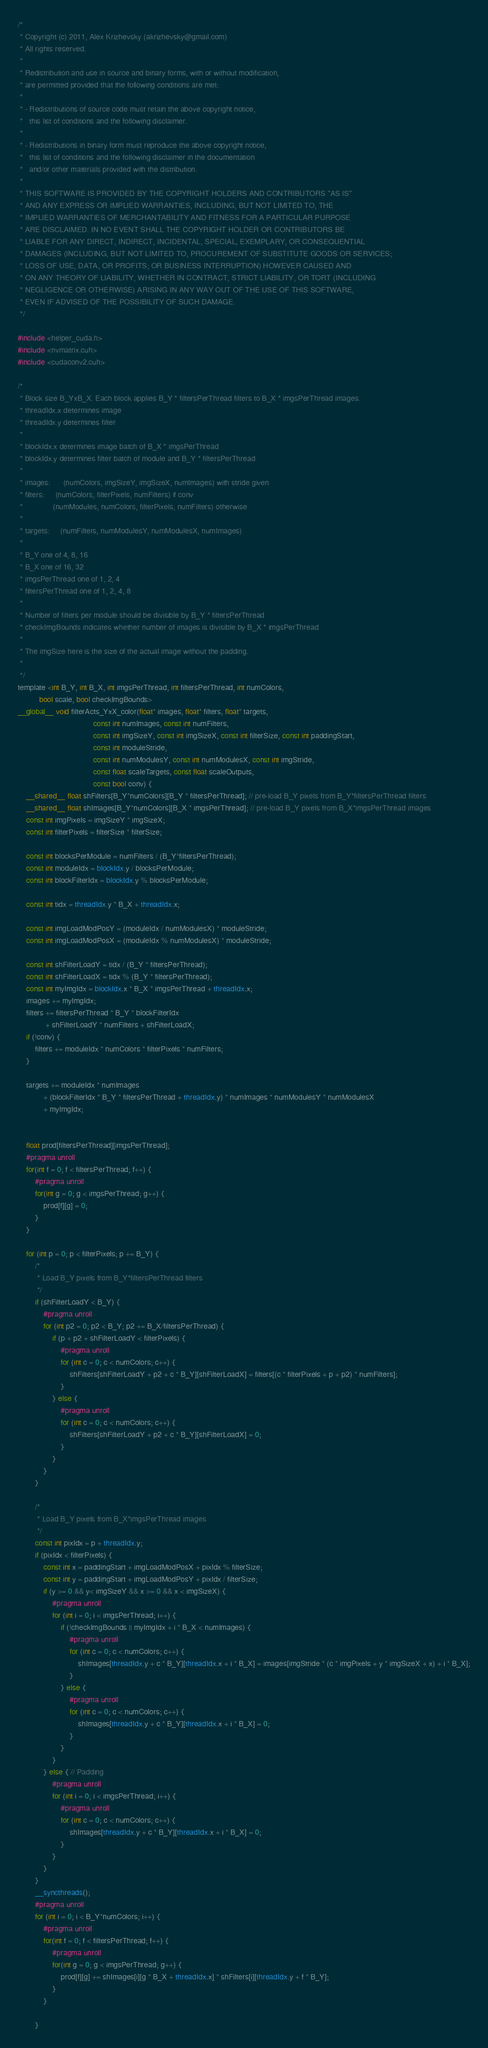<code> <loc_0><loc_0><loc_500><loc_500><_Cuda_>/* 
 * Copyright (c) 2011, Alex Krizhevsky (akrizhevsky@gmail.com)
 * All rights reserved.
 *
 * Redistribution and use in source and binary forms, with or without modification,
 * are permitted provided that the following conditions are met:
 *
 * - Redistributions of source code must retain the above copyright notice,
 *   this list of conditions and the following disclaimer.
 * 
 * - Redistributions in binary form must reproduce the above copyright notice,
 *   this list of conditions and the following disclaimer in the documentation
 *   and/or other materials provided with the distribution.
 *
 * THIS SOFTWARE IS PROVIDED BY THE COPYRIGHT HOLDERS AND CONTRIBUTORS "AS IS"
 * AND ANY EXPRESS OR IMPLIED WARRANTIES, INCLUDING, BUT NOT LIMITED TO, THE
 * IMPLIED WARRANTIES OF MERCHANTABILITY AND FITNESS FOR A PARTICULAR PURPOSE
 * ARE DISCLAIMED. IN NO EVENT SHALL THE COPYRIGHT HOLDER OR CONTRIBUTORS BE
 * LIABLE FOR ANY DIRECT, INDIRECT, INCIDENTAL, SPECIAL, EXEMPLARY, OR CONSEQUENTIAL
 * DAMAGES (INCLUDING, BUT NOT LIMITED TO, PROCUREMENT OF SUBSTITUTE GOODS OR SERVICES;
 * LOSS OF USE, DATA, OR PROFITS; OR BUSINESS INTERRUPTION) HOWEVER CAUSED AND
 * ON ANY THEORY OF LIABILITY, WHETHER IN CONTRACT, STRICT LIABILITY, OR TORT (INCLUDING
 * NEGLIGENCE OR OTHERWISE) ARISING IN ANY WAY OUT OF THE USE OF THIS SOFTWARE,
 * EVEN IF ADVISED OF THE POSSIBILITY OF SUCH DAMAGE.
 */

#include <helper_cuda.h>
#include <nvmatrix.cuh>
#include <cudaconv2.cuh>

/*
 * Block size B_YxB_X. Each block applies B_Y * filtersPerThread filters to B_X * imgsPerThread images.
 * threadIdx.x determines image
 * threadIdx.y determines filter
 *
 * blockIdx.x determines image batch of B_X * imgsPerThread
 * blockIdx.y determines filter batch of module and B_Y * filtersPerThread
 *
 * images:      (numColors, imgSizeY, imgSizeX, numImages) with stride given
 * filters:     (numColors, filterPixels, numFilters) if conv
 *              (numModules, numColors, filterPixels, numFilters) otherwise
 *
 * targets:     (numFilters, numModulesY, numModulesX, numImages)
 *
 * B_Y one of 4, 8, 16
 * B_X one of 16, 32
 * imgsPerThread one of 1, 2, 4
 * filtersPerThread one of 1, 2, 4, 8
 *
 * Number of filters per module should be divisible by B_Y * filtersPerThread
 * checkImgBounds indicates whether number of images is divisible by B_X * imgsPerThread
 *
 * The imgSize here is the size of the actual image without the padding.
 *
 */
template <int B_Y, int B_X, int imgsPerThread, int filtersPerThread, int numColors,
          bool scale, bool checkImgBounds>
__global__ void filterActs_YxX_color(float* images, float* filters, float* targets,
                                   const int numImages, const int numFilters,
                                   const int imgSizeY, const int imgSizeX, const int filterSize, const int paddingStart,
                                   const int moduleStride,
                                   const int numModulesY, const int numModulesX, const int imgStride,
                                   const float scaleTargets, const float scaleOutputs,
                                   const bool conv) {
    __shared__ float shFilters[B_Y*numColors][B_Y * filtersPerThread]; // pre-load B_Y pixels from B_Y*filtersPerThread filters
    __shared__ float shImages[B_Y*numColors][B_X * imgsPerThread]; // pre-load B_Y pixels from B_X*imgsPerThread images
    const int imgPixels = imgSizeY * imgSizeX;
    const int filterPixels = filterSize * filterSize;

    const int blocksPerModule = numFilters / (B_Y*filtersPerThread);
    const int moduleIdx = blockIdx.y / blocksPerModule;
    const int blockFilterIdx = blockIdx.y % blocksPerModule;

    const int tidx = threadIdx.y * B_X + threadIdx.x;

    const int imgLoadModPosY = (moduleIdx / numModulesX) * moduleStride;
    const int imgLoadModPosX = (moduleIdx % numModulesX) * moduleStride;

    const int shFilterLoadY = tidx / (B_Y * filtersPerThread);
    const int shFilterLoadX = tidx % (B_Y * filtersPerThread);
    const int myImgIdx = blockIdx.x * B_X * imgsPerThread + threadIdx.x;
    images += myImgIdx;
    filters += filtersPerThread * B_Y * blockFilterIdx
             + shFilterLoadY * numFilters + shFilterLoadX;
    if (!conv) {
        filters += moduleIdx * numColors * filterPixels * numFilters;
    }

    targets += moduleIdx * numImages
            + (blockFilterIdx * B_Y * filtersPerThread + threadIdx.y) * numImages * numModulesY * numModulesX
            + myImgIdx;


    float prod[filtersPerThread][imgsPerThread];
    #pragma unroll
    for(int f = 0; f < filtersPerThread; f++) {
        #pragma unroll
        for(int g = 0; g < imgsPerThread; g++) {
            prod[f][g] = 0;
        }
    }

    for (int p = 0; p < filterPixels; p += B_Y) {
        /*
         * Load B_Y pixels from B_Y*filtersPerThread filters
         */
        if (shFilterLoadY < B_Y) {
            #pragma unroll
            for (int p2 = 0; p2 < B_Y; p2 += B_X/filtersPerThread) {
                if (p + p2 + shFilterLoadY < filterPixels) {
                    #pragma unroll
                    for (int c = 0; c < numColors; c++) {
                        shFilters[shFilterLoadY + p2 + c * B_Y][shFilterLoadX] = filters[(c * filterPixels + p + p2) * numFilters];
                    }
                } else {
                    #pragma unroll
                    for (int c = 0; c < numColors; c++) {
                        shFilters[shFilterLoadY + p2 + c * B_Y][shFilterLoadX] = 0;
                    }
                }
            }
        }

        /*
         * Load B_Y pixels from B_X*imgsPerThread images
         */
        const int pixIdx = p + threadIdx.y;
        if (pixIdx < filterPixels) {
            const int x = paddingStart + imgLoadModPosX + pixIdx % filterSize;
            const int y = paddingStart + imgLoadModPosY + pixIdx / filterSize;
            if (y >= 0 && y< imgSizeY && x >= 0 && x < imgSizeX) {
                #pragma unroll
                for (int i = 0; i < imgsPerThread; i++) {
                    if (!checkImgBounds || myImgIdx + i * B_X < numImages) {
                        #pragma unroll
                        for (int c = 0; c < numColors; c++) {
                            shImages[threadIdx.y + c * B_Y][threadIdx.x + i * B_X] = images[imgStride * (c * imgPixels + y * imgSizeX + x) + i * B_X];
                        }
                    } else {
                        #pragma unroll
                        for (int c = 0; c < numColors; c++) {
                            shImages[threadIdx.y + c * B_Y][threadIdx.x + i * B_X] = 0;
                        }
                    }
                }
            } else { // Padding
                #pragma unroll
                for (int i = 0; i < imgsPerThread; i++) {
                    #pragma unroll
                    for (int c = 0; c < numColors; c++) {
                        shImages[threadIdx.y + c * B_Y][threadIdx.x + i * B_X] = 0;
                    }
                }
            }
        }
        __syncthreads();
        #pragma unroll
        for (int i = 0; i < B_Y*numColors; i++) {
            #pragma unroll
            for(int f = 0; f < filtersPerThread; f++) {
                #pragma unroll
                for(int g = 0; g < imgsPerThread; g++) {
                    prod[f][g] += shImages[i][g * B_X + threadIdx.x] * shFilters[i][threadIdx.y + f * B_Y];
                }
            }

        }</code> 